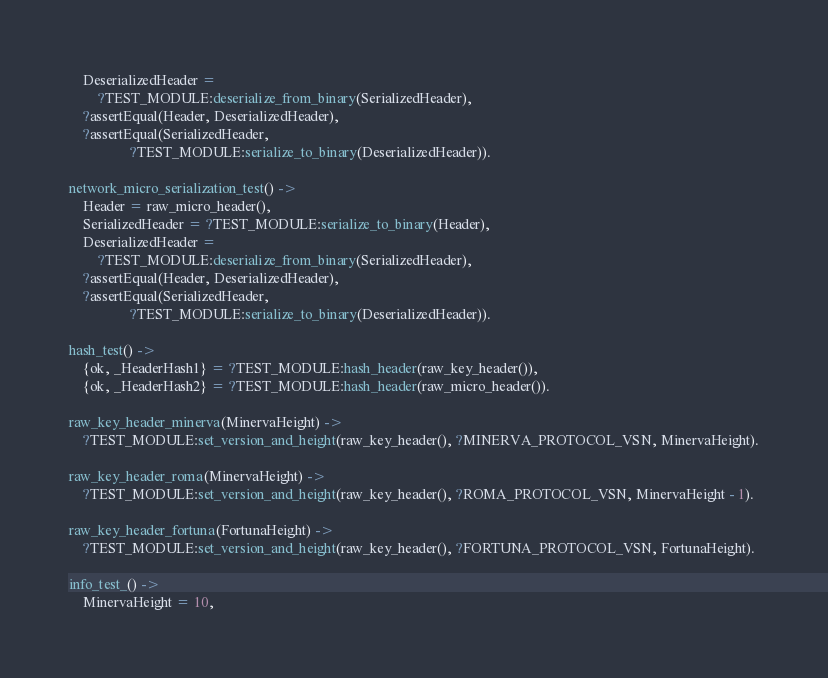Convert code to text. <code><loc_0><loc_0><loc_500><loc_500><_Erlang_>    DeserializedHeader =
        ?TEST_MODULE:deserialize_from_binary(SerializedHeader),
    ?assertEqual(Header, DeserializedHeader),
    ?assertEqual(SerializedHeader,
                 ?TEST_MODULE:serialize_to_binary(DeserializedHeader)).

network_micro_serialization_test() ->
    Header = raw_micro_header(),
    SerializedHeader = ?TEST_MODULE:serialize_to_binary(Header),
    DeserializedHeader =
        ?TEST_MODULE:deserialize_from_binary(SerializedHeader),
    ?assertEqual(Header, DeserializedHeader),
    ?assertEqual(SerializedHeader,
                 ?TEST_MODULE:serialize_to_binary(DeserializedHeader)).

hash_test() ->
    {ok, _HeaderHash1} = ?TEST_MODULE:hash_header(raw_key_header()),
    {ok, _HeaderHash2} = ?TEST_MODULE:hash_header(raw_micro_header()).

raw_key_header_minerva(MinervaHeight) ->
    ?TEST_MODULE:set_version_and_height(raw_key_header(), ?MINERVA_PROTOCOL_VSN, MinervaHeight).

raw_key_header_roma(MinervaHeight) ->
    ?TEST_MODULE:set_version_and_height(raw_key_header(), ?ROMA_PROTOCOL_VSN, MinervaHeight - 1).

raw_key_header_fortuna(FortunaHeight) ->
    ?TEST_MODULE:set_version_and_height(raw_key_header(), ?FORTUNA_PROTOCOL_VSN, FortunaHeight).

info_test_() ->
    MinervaHeight = 10,</code> 